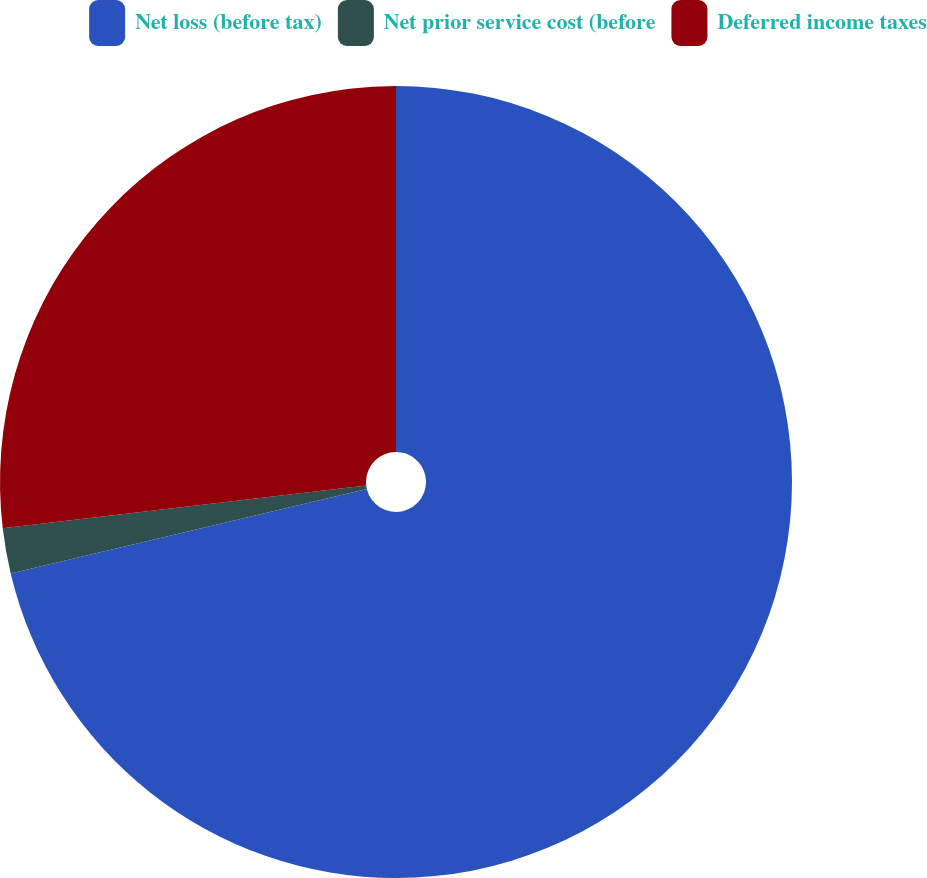<chart> <loc_0><loc_0><loc_500><loc_500><pie_chart><fcel>Net loss (before tax)<fcel>Net prior service cost (before<fcel>Deferred income taxes<nl><fcel>71.3%<fcel>1.84%<fcel>26.87%<nl></chart> 